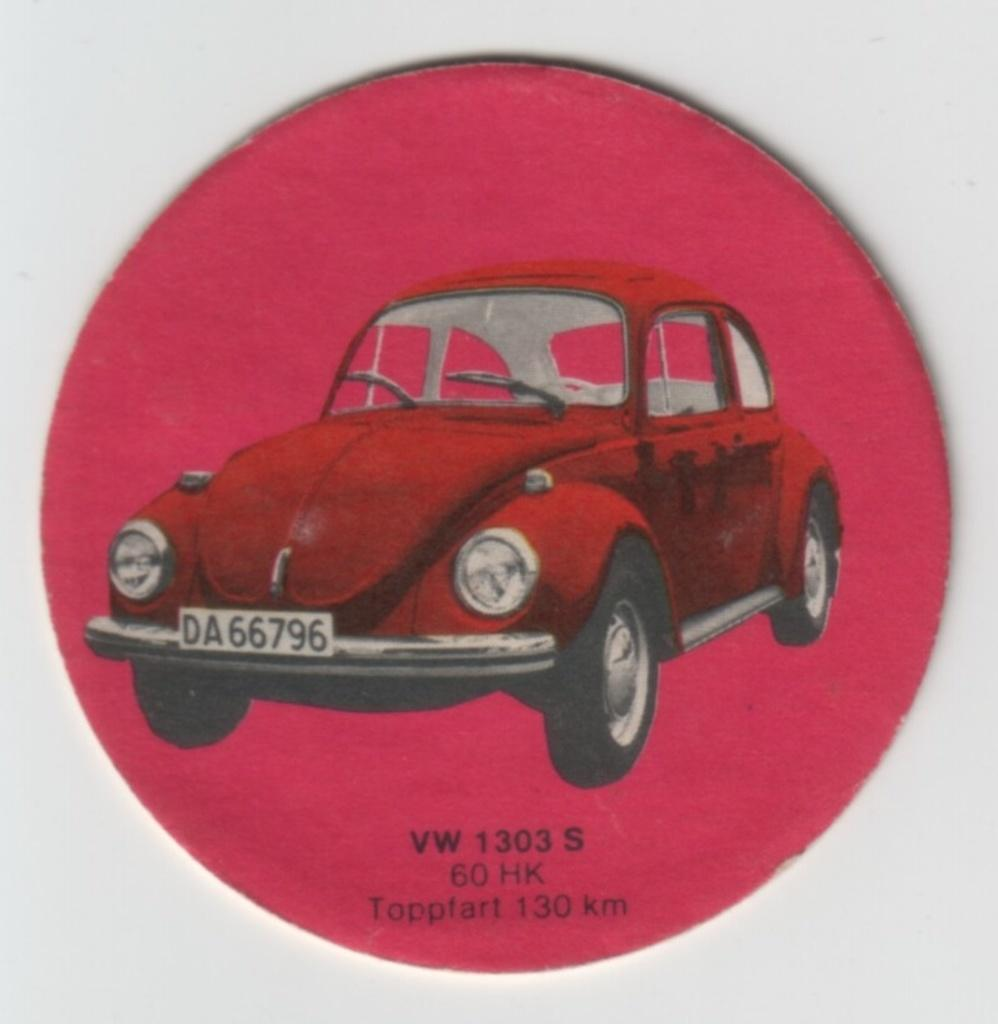What color is the prominent object in the image? The prominent object in the image is red. What is depicted on the red object? The red object has a depiction of a car. Is there any text present on the red object? Yes, there is text written on the bottom side of the red object. Can you tell me the name of the bone that is visible in the image? There is no bone present in the image; it features a red object with a car depiction and text. Is the red object a chair in the image? No, the red object is not a chair; it has a car depiction and text. 